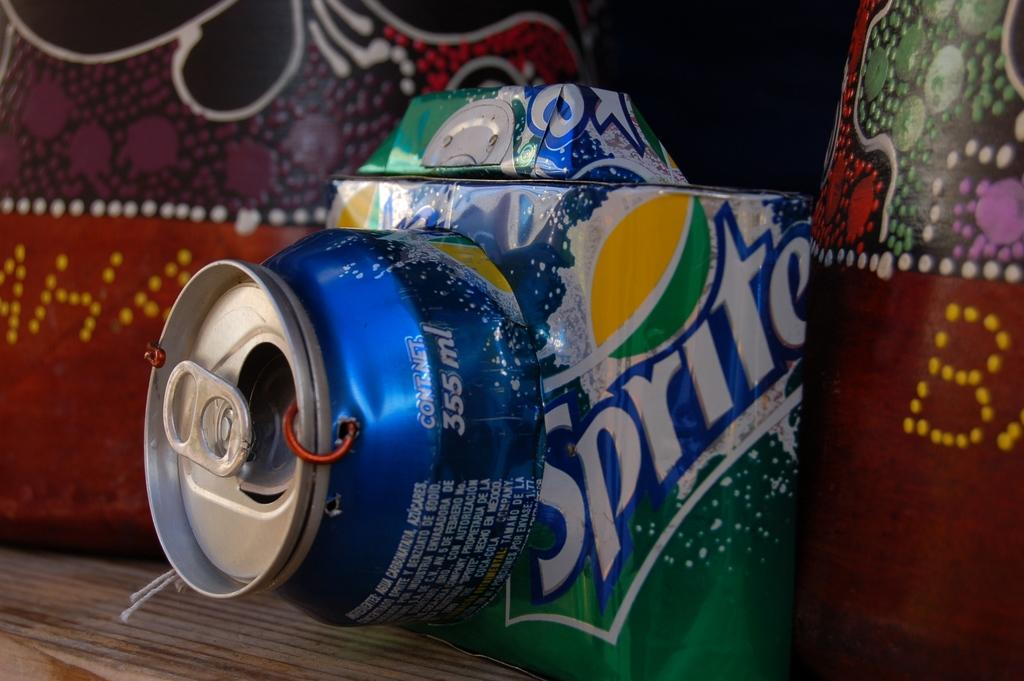What type of beverage can is present in the image? There is a sprite can in the image. What can be seen on the wall in the image? There is a painting on the wall in the image. How many tickets are visible in the image? There are no tickets present in the image. What type of skin is visible on the painting in the image? The painting in the image is not a representation of any living being, so there is no skin visible. 